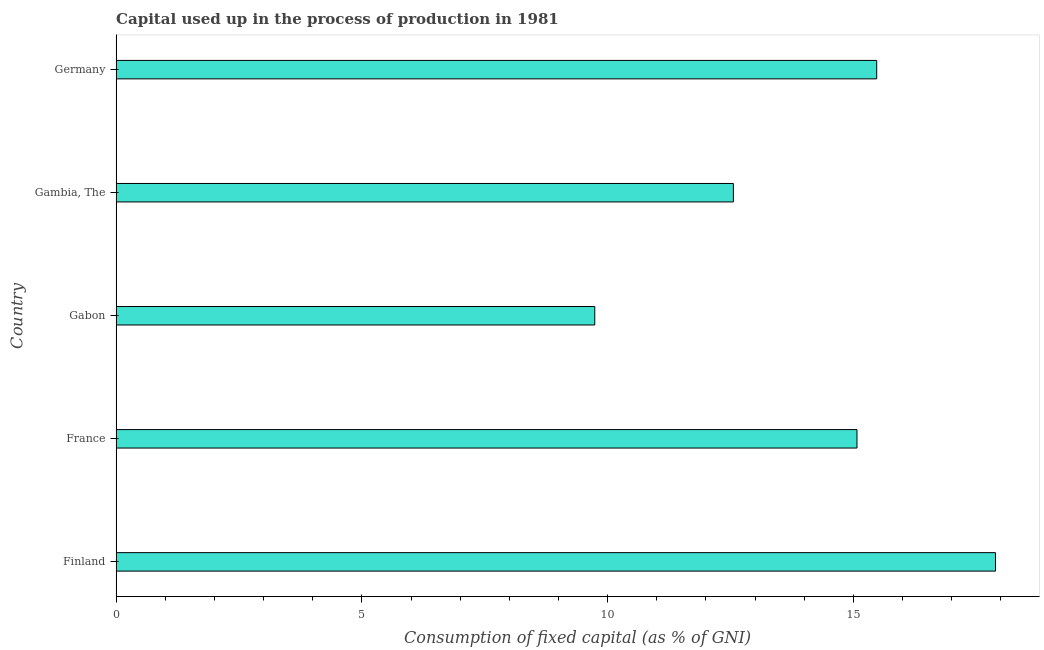Does the graph contain grids?
Keep it short and to the point. No. What is the title of the graph?
Make the answer very short. Capital used up in the process of production in 1981. What is the label or title of the X-axis?
Keep it short and to the point. Consumption of fixed capital (as % of GNI). What is the consumption of fixed capital in Gabon?
Keep it short and to the point. 9.74. Across all countries, what is the maximum consumption of fixed capital?
Your response must be concise. 17.89. Across all countries, what is the minimum consumption of fixed capital?
Make the answer very short. 9.74. In which country was the consumption of fixed capital minimum?
Provide a succinct answer. Gabon. What is the sum of the consumption of fixed capital?
Offer a very short reply. 70.73. What is the difference between the consumption of fixed capital in Finland and Gabon?
Your response must be concise. 8.15. What is the average consumption of fixed capital per country?
Your response must be concise. 14.15. What is the median consumption of fixed capital?
Give a very brief answer. 15.07. In how many countries, is the consumption of fixed capital greater than 8 %?
Offer a very short reply. 5. What is the ratio of the consumption of fixed capital in Gabon to that in Gambia, The?
Your answer should be compact. 0.78. Is the consumption of fixed capital in Gambia, The less than that in Germany?
Keep it short and to the point. Yes. Is the difference between the consumption of fixed capital in Finland and France greater than the difference between any two countries?
Ensure brevity in your answer.  No. What is the difference between the highest and the second highest consumption of fixed capital?
Give a very brief answer. 2.42. What is the difference between the highest and the lowest consumption of fixed capital?
Give a very brief answer. 8.15. Are all the bars in the graph horizontal?
Offer a very short reply. Yes. What is the difference between two consecutive major ticks on the X-axis?
Offer a terse response. 5. Are the values on the major ticks of X-axis written in scientific E-notation?
Your response must be concise. No. What is the Consumption of fixed capital (as % of GNI) of Finland?
Keep it short and to the point. 17.89. What is the Consumption of fixed capital (as % of GNI) in France?
Your answer should be very brief. 15.07. What is the Consumption of fixed capital (as % of GNI) of Gabon?
Make the answer very short. 9.74. What is the Consumption of fixed capital (as % of GNI) of Gambia, The?
Offer a terse response. 12.56. What is the Consumption of fixed capital (as % of GNI) of Germany?
Make the answer very short. 15.47. What is the difference between the Consumption of fixed capital (as % of GNI) in Finland and France?
Provide a succinct answer. 2.82. What is the difference between the Consumption of fixed capital (as % of GNI) in Finland and Gabon?
Offer a very short reply. 8.15. What is the difference between the Consumption of fixed capital (as % of GNI) in Finland and Gambia, The?
Ensure brevity in your answer.  5.33. What is the difference between the Consumption of fixed capital (as % of GNI) in Finland and Germany?
Offer a very short reply. 2.42. What is the difference between the Consumption of fixed capital (as % of GNI) in France and Gabon?
Keep it short and to the point. 5.33. What is the difference between the Consumption of fixed capital (as % of GNI) in France and Gambia, The?
Provide a succinct answer. 2.51. What is the difference between the Consumption of fixed capital (as % of GNI) in France and Germany?
Your answer should be compact. -0.4. What is the difference between the Consumption of fixed capital (as % of GNI) in Gabon and Gambia, The?
Your answer should be very brief. -2.82. What is the difference between the Consumption of fixed capital (as % of GNI) in Gabon and Germany?
Your answer should be very brief. -5.74. What is the difference between the Consumption of fixed capital (as % of GNI) in Gambia, The and Germany?
Make the answer very short. -2.92. What is the ratio of the Consumption of fixed capital (as % of GNI) in Finland to that in France?
Your answer should be very brief. 1.19. What is the ratio of the Consumption of fixed capital (as % of GNI) in Finland to that in Gabon?
Ensure brevity in your answer.  1.84. What is the ratio of the Consumption of fixed capital (as % of GNI) in Finland to that in Gambia, The?
Provide a succinct answer. 1.43. What is the ratio of the Consumption of fixed capital (as % of GNI) in Finland to that in Germany?
Your response must be concise. 1.16. What is the ratio of the Consumption of fixed capital (as % of GNI) in France to that in Gabon?
Make the answer very short. 1.55. What is the ratio of the Consumption of fixed capital (as % of GNI) in France to that in Gambia, The?
Your response must be concise. 1.2. What is the ratio of the Consumption of fixed capital (as % of GNI) in Gabon to that in Gambia, The?
Give a very brief answer. 0.78. What is the ratio of the Consumption of fixed capital (as % of GNI) in Gabon to that in Germany?
Keep it short and to the point. 0.63. What is the ratio of the Consumption of fixed capital (as % of GNI) in Gambia, The to that in Germany?
Ensure brevity in your answer.  0.81. 